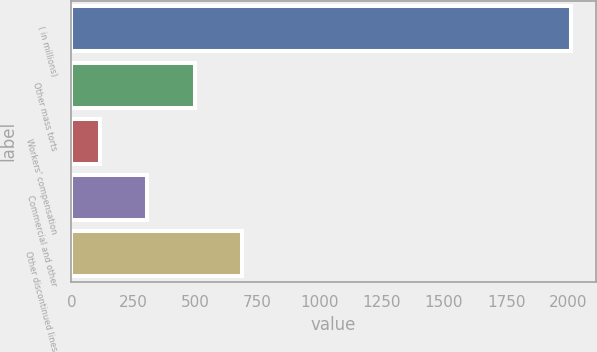<chart> <loc_0><loc_0><loc_500><loc_500><bar_chart><fcel>( in millions)<fcel>Other mass torts<fcel>Workers' compensation<fcel>Commercial and other<fcel>Other discontinued lines<nl><fcel>2011<fcel>495.8<fcel>117<fcel>306.4<fcel>685.2<nl></chart> 